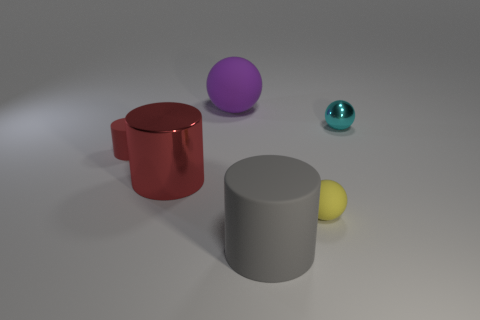What number of big matte cubes are the same color as the large metal object?
Offer a terse response. 0. There is a object that is the same material as the cyan ball; what shape is it?
Give a very brief answer. Cylinder. What is the size of the cylinder to the left of the big red shiny object?
Make the answer very short. Small. Are there the same number of shiny cylinders on the left side of the small cylinder and purple rubber objects in front of the gray object?
Offer a very short reply. Yes. There is a small sphere that is behind the tiny matte thing that is on the right side of the shiny object that is in front of the cyan metal ball; what color is it?
Give a very brief answer. Cyan. What number of objects are in front of the small red cylinder and right of the large shiny cylinder?
Provide a succinct answer. 2. Is the color of the small matte object left of the large gray cylinder the same as the large rubber object that is behind the large red cylinder?
Provide a short and direct response. No. Is there any other thing that has the same material as the purple sphere?
Your answer should be compact. Yes. There is a purple matte thing that is the same shape as the small yellow matte thing; what is its size?
Provide a short and direct response. Large. Are there any red matte cylinders behind the cyan sphere?
Provide a succinct answer. No. 